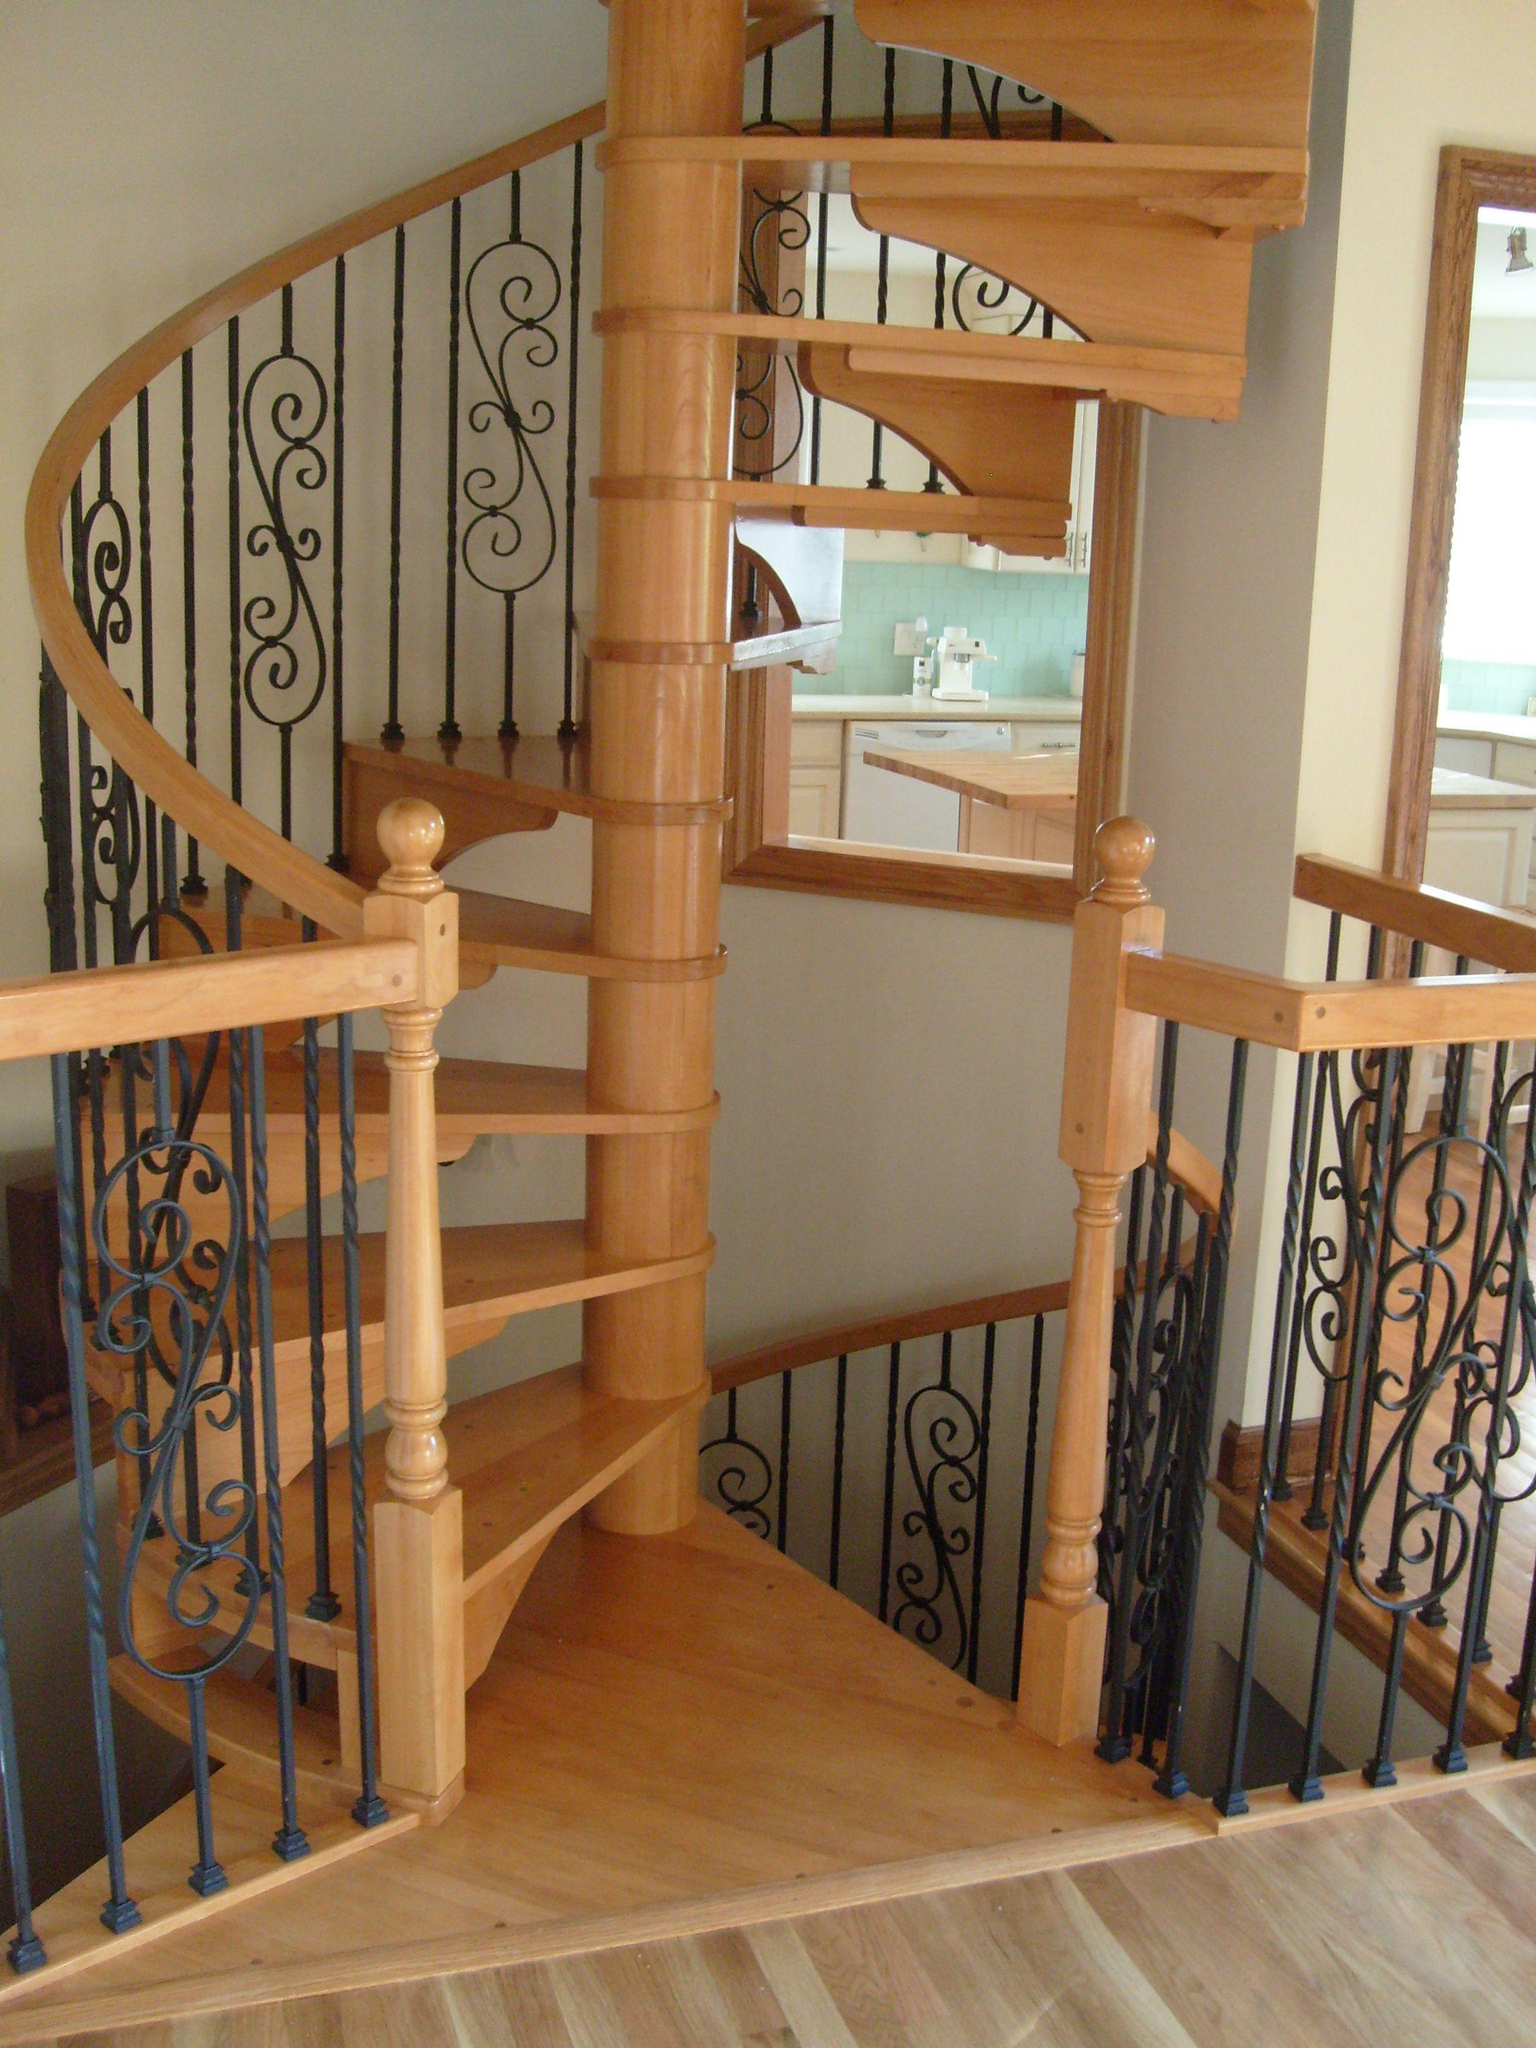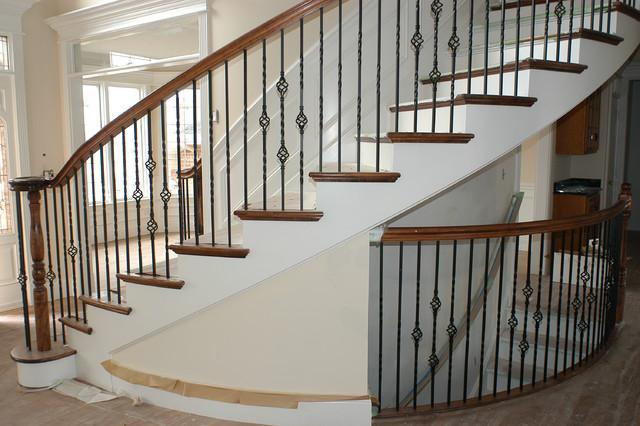The first image is the image on the left, the second image is the image on the right. Evaluate the accuracy of this statement regarding the images: "In at least one image there is  a set of stairs point left forward with the bottom step longer than the rest.". Is it true? Answer yes or no. No. The first image is the image on the left, the second image is the image on the right. Given the left and right images, does the statement "The right image shows a curving staircase with brown steps and white baseboards, a curving brown rail, and black wrought iron bars." hold true? Answer yes or no. Yes. 